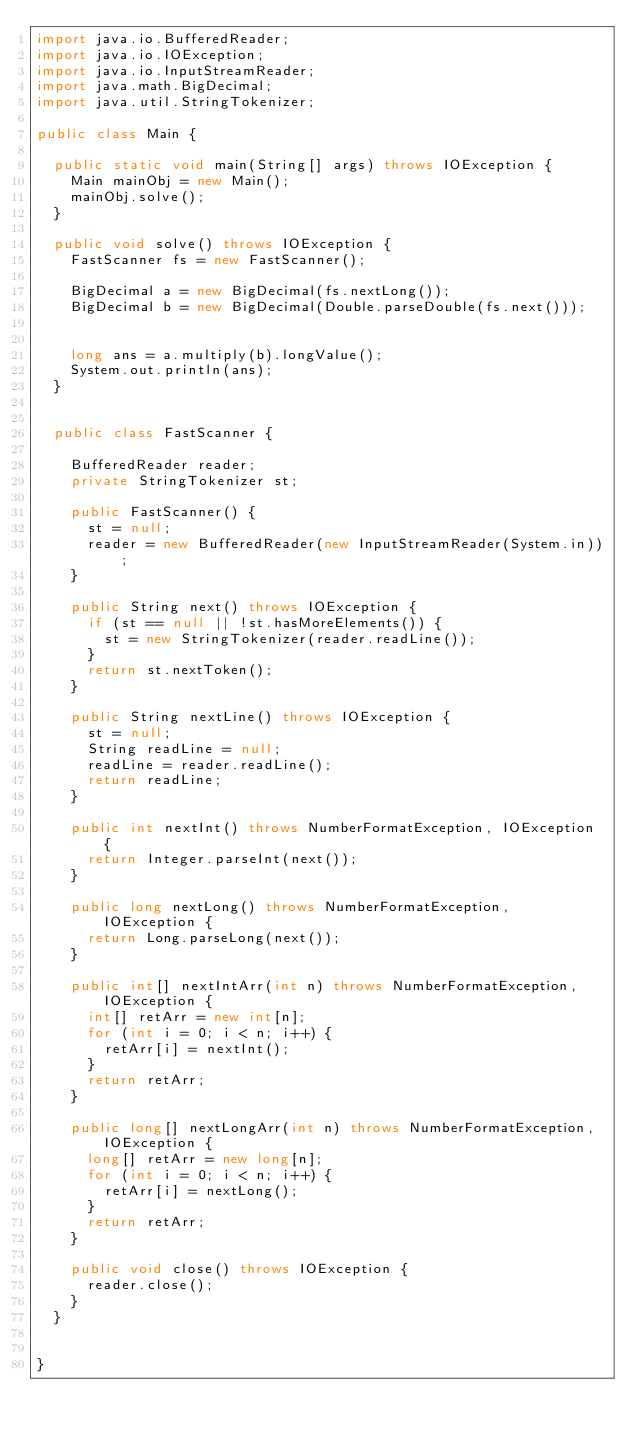Convert code to text. <code><loc_0><loc_0><loc_500><loc_500><_Java_>import java.io.BufferedReader;
import java.io.IOException;
import java.io.InputStreamReader;
import java.math.BigDecimal;
import java.util.StringTokenizer;

public class Main {
	
	public static void main(String[] args) throws IOException {
		Main mainObj = new Main();
		mainObj.solve();
	}

	public void solve() throws IOException {
		FastScanner fs = new FastScanner();
		
		BigDecimal a = new BigDecimal(fs.nextLong());
		BigDecimal b = new BigDecimal(Double.parseDouble(fs.next()));
		
		
		long ans = a.multiply(b).longValue();
		System.out.println(ans);
	}
	

	public class FastScanner {

		BufferedReader reader;
		private StringTokenizer st;

		public FastScanner() {
			st = null;
			reader = new BufferedReader(new InputStreamReader(System.in));
		}

		public String next() throws IOException {
			if (st == null || !st.hasMoreElements()) {
				st = new StringTokenizer(reader.readLine());
			}
			return st.nextToken();
		}

		public String nextLine() throws IOException {
			st = null;
			String readLine = null;
			readLine = reader.readLine();
			return readLine;
		}

		public int nextInt() throws NumberFormatException, IOException {
			return Integer.parseInt(next());
		}

		public long nextLong() throws NumberFormatException, IOException {
			return Long.parseLong(next());
		}

		public int[] nextIntArr(int n) throws NumberFormatException, IOException {
			int[] retArr = new int[n];
			for (int i = 0; i < n; i++) {
				retArr[i] = nextInt();
			}
			return retArr;
		}

		public long[] nextLongArr(int n) throws NumberFormatException, IOException {
			long[] retArr = new long[n];
			for (int i = 0; i < n; i++) {
				retArr[i] = nextLong();
			}
			return retArr;
		}

		public void close() throws IOException {
			reader.close();
		}
	}


}
</code> 